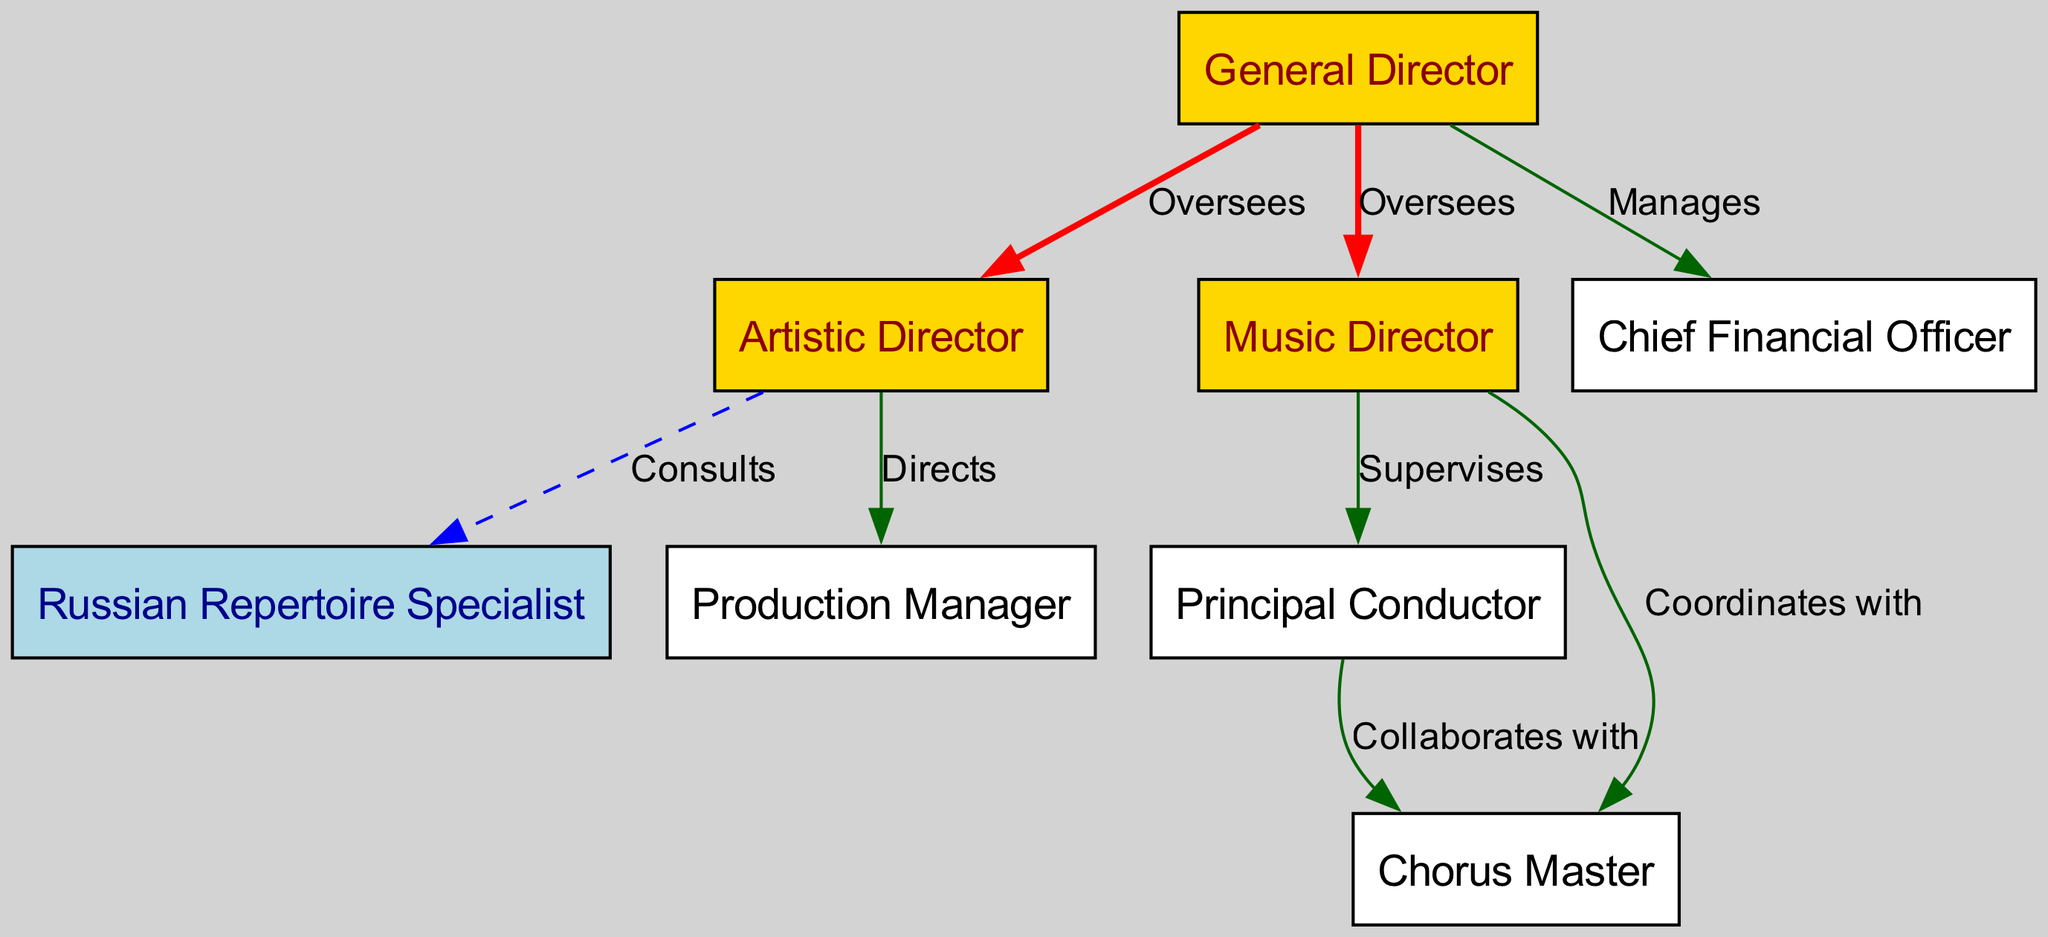What is the role that oversees the Artistic Director? The diagram shows a directed edge labeled "Oversees" from the General Director to the Artistic Director. Thus, the General Director is responsible for overseeing this role.
Answer: General Director How many nodes are present in the diagram? By counting each entry under the nodes section of the diagram data, there are eight distinct roles, which represent the nodes in the graph.
Answer: Eight Which role coordinates with the Chorus Master? The directed edge labeled "Coordinates with" indicates that the Music Director coordinates with the Chorus Master.
Answer: Music Director What is the relationship type between the Music Director and the Principal Conductor? The diagram specifies that the Music Director "Supervises" the Principal Conductor, indicating a direct supervisory relationship between these two roles.
Answer: Supervises Which roles does the General Director manage directly? There are directed edges labeled "Manages" from the General Director to the Chief Financial Officer, showing that this is the direct management responsibility of the General Director.
Answer: Chief Financial Officer Which role consults with the Artistic Director? As seen in the diagram, the Artistic Director has a dashed edge labeled "Consults" to the Russian Repertoire Specialist, meaning that the Artistic Director consults with this specific role.
Answer: Russian Repertoire Specialist What type of edge connects the Production Manager and the Artistic Director? In the diagram, the Production Manager is connected to the Artistic Director through a directed edge labeled "Directs." This indicates a directive relationship.
Answer: Directs How many edges are there in total in the diagram? By counting the directed edges listed in the relationships section of the diagram data, there are seven connections shown, which represent the total edges.
Answer: Seven Which two roles collaborate directly according to the diagram? The directed edge labeled "Collaborates with" connects the Principal Conductor and the Chorus Master, indicating that these two roles have a direct collaboration relationship.
Answer: Principal Conductor and Chorus Master 